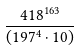<formula> <loc_0><loc_0><loc_500><loc_500>\frac { 4 1 8 ^ { 1 6 3 } } { ( 1 9 7 ^ { 4 } \cdot 1 0 ) }</formula> 